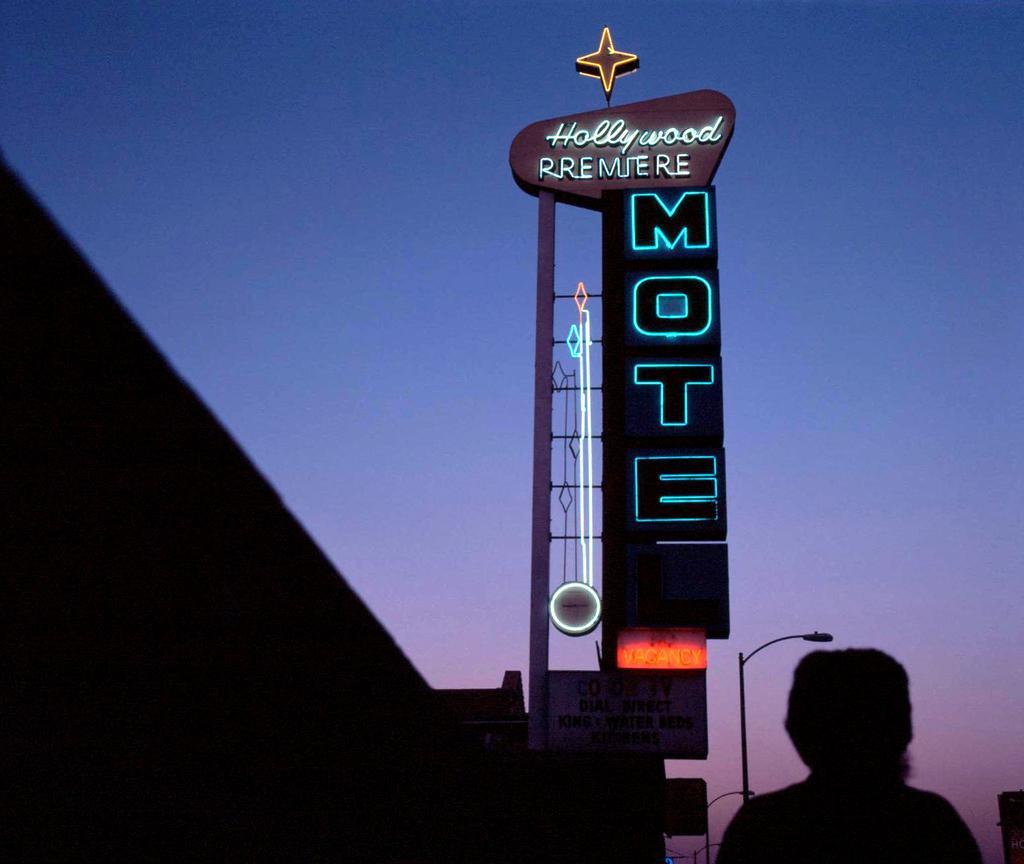Could you give a brief overview of what you see in this image? In front of the image there is a person, beside the person there is neon sign and a building and there is a lamppost. 